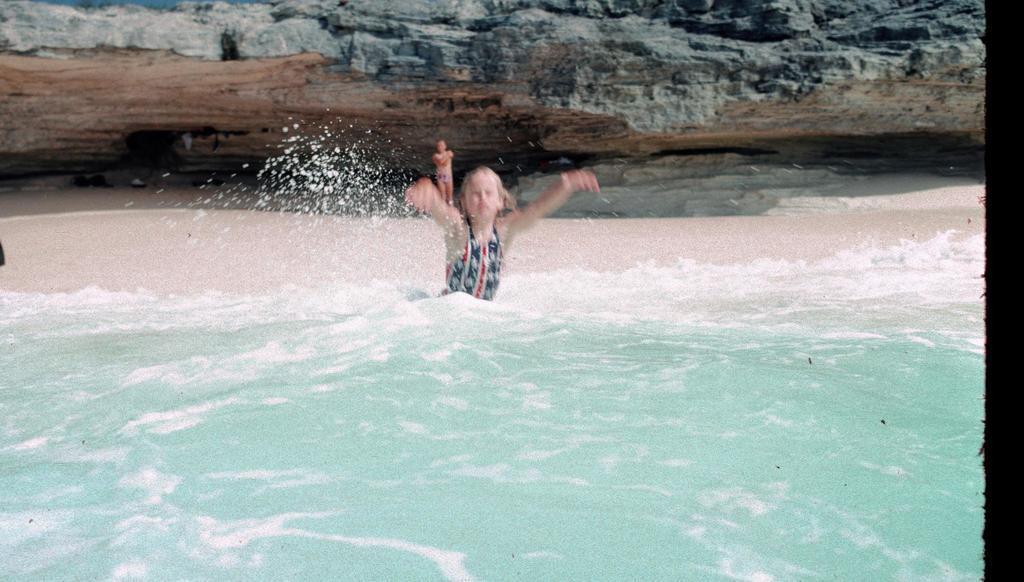In one or two sentences, can you explain what this image depicts? In the foreground of the picture there is a water body. In the center can see a person. In the background we can see sand, rock and a person standing. 